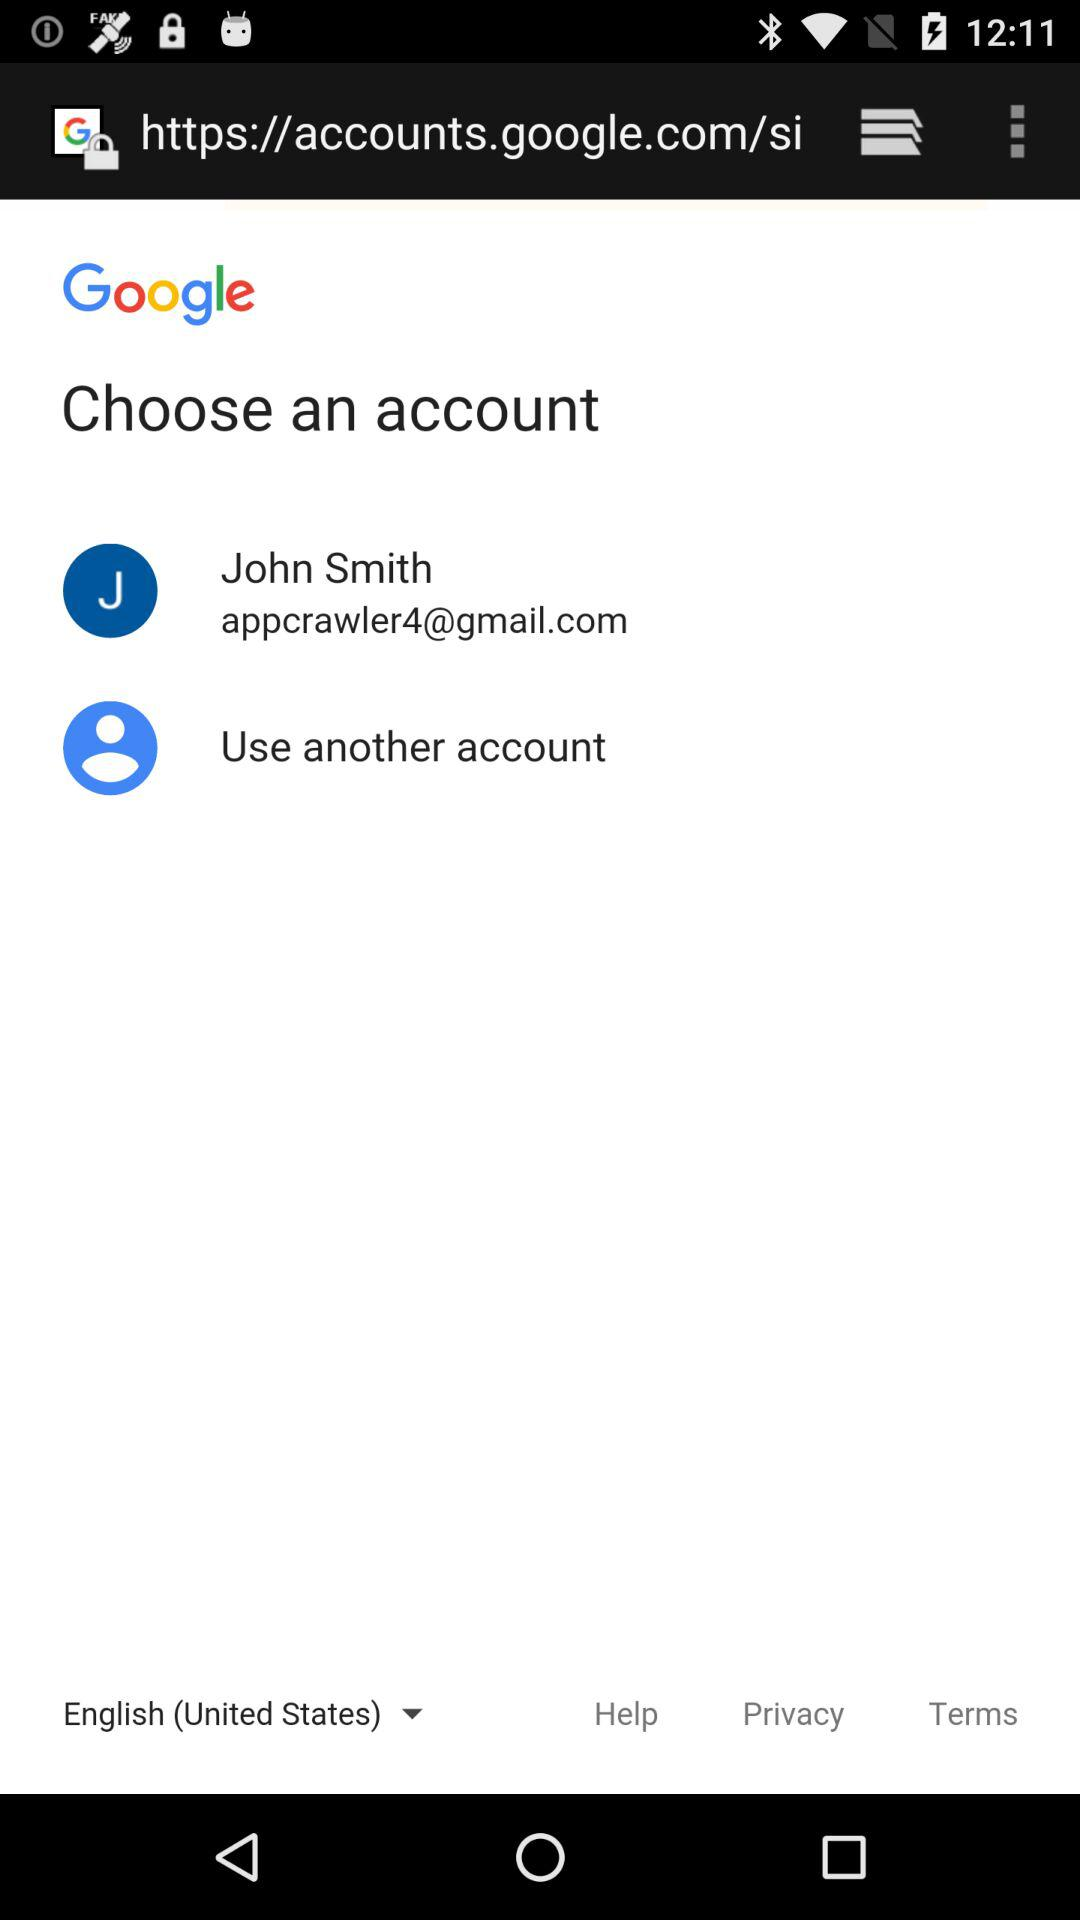What is the email address? The email address is "appcrawler4@gmail.com". 